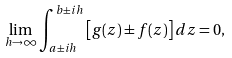<formula> <loc_0><loc_0><loc_500><loc_500>\lim _ { h \to \infty } \int _ { a \pm i h } ^ { b \pm i h } { \left [ g ( z ) \pm f ( z ) \right ] d z } = 0 ,</formula> 